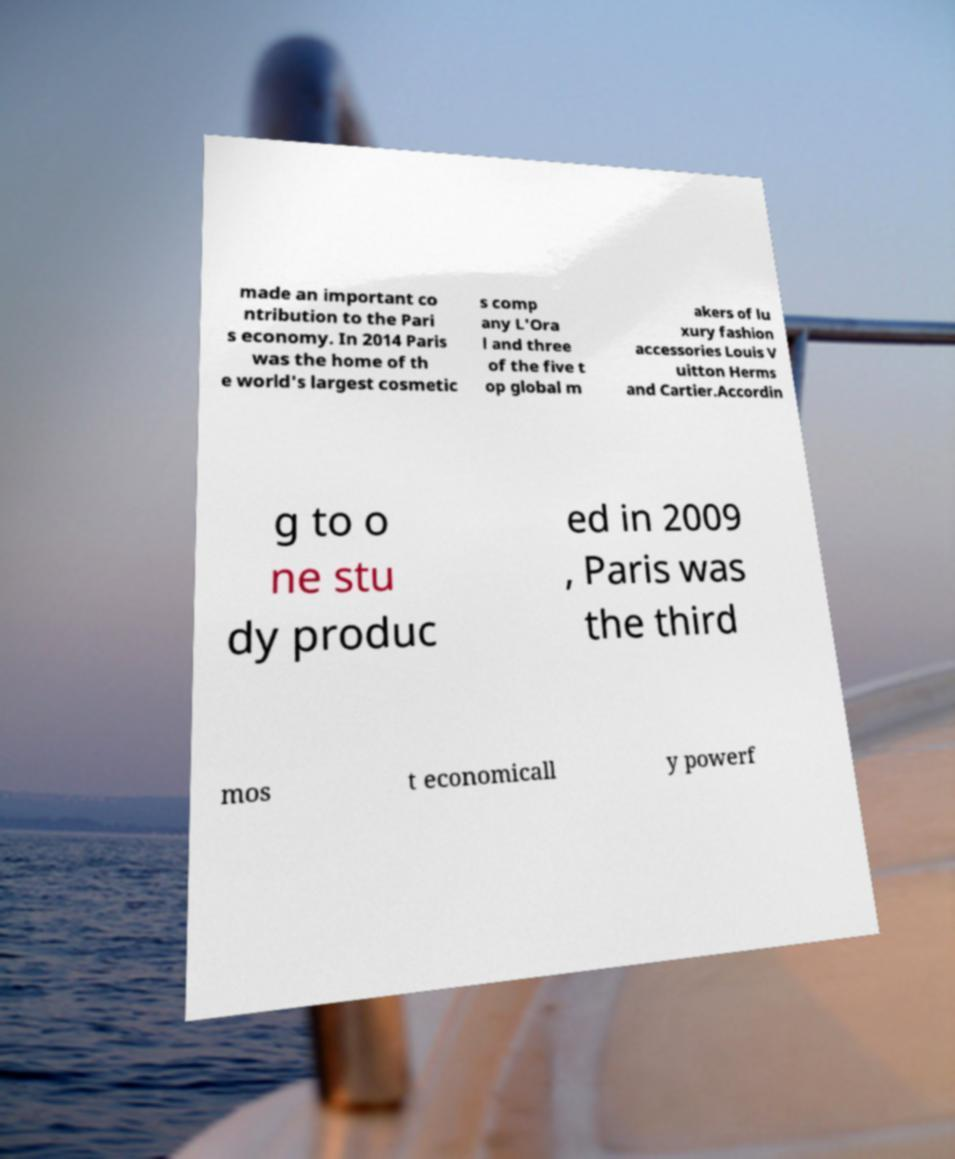For documentation purposes, I need the text within this image transcribed. Could you provide that? made an important co ntribution to the Pari s economy. In 2014 Paris was the home of th e world's largest cosmetic s comp any L'Ora l and three of the five t op global m akers of lu xury fashion accessories Louis V uitton Herms and Cartier.Accordin g to o ne stu dy produc ed in 2009 , Paris was the third mos t economicall y powerf 